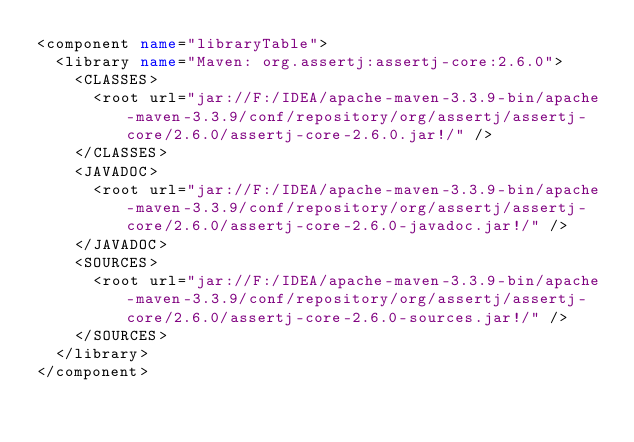<code> <loc_0><loc_0><loc_500><loc_500><_XML_><component name="libraryTable">
  <library name="Maven: org.assertj:assertj-core:2.6.0">
    <CLASSES>
      <root url="jar://F:/IDEA/apache-maven-3.3.9-bin/apache-maven-3.3.9/conf/repository/org/assertj/assertj-core/2.6.0/assertj-core-2.6.0.jar!/" />
    </CLASSES>
    <JAVADOC>
      <root url="jar://F:/IDEA/apache-maven-3.3.9-bin/apache-maven-3.3.9/conf/repository/org/assertj/assertj-core/2.6.0/assertj-core-2.6.0-javadoc.jar!/" />
    </JAVADOC>
    <SOURCES>
      <root url="jar://F:/IDEA/apache-maven-3.3.9-bin/apache-maven-3.3.9/conf/repository/org/assertj/assertj-core/2.6.0/assertj-core-2.6.0-sources.jar!/" />
    </SOURCES>
  </library>
</component></code> 